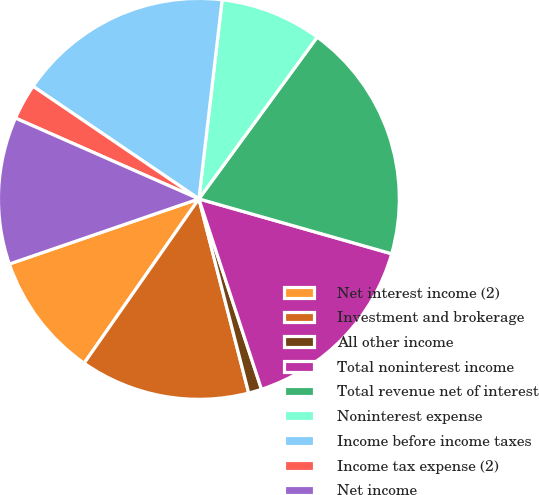Convert chart. <chart><loc_0><loc_0><loc_500><loc_500><pie_chart><fcel>Net interest income (2)<fcel>Investment and brokerage<fcel>All other income<fcel>Total noninterest income<fcel>Total revenue net of interest<fcel>Noninterest expense<fcel>Income before income taxes<fcel>Income tax expense (2)<fcel>Net income<nl><fcel>10.03%<fcel>13.7%<fcel>1.06%<fcel>15.53%<fcel>19.37%<fcel>8.2%<fcel>17.36%<fcel>2.89%<fcel>11.87%<nl></chart> 